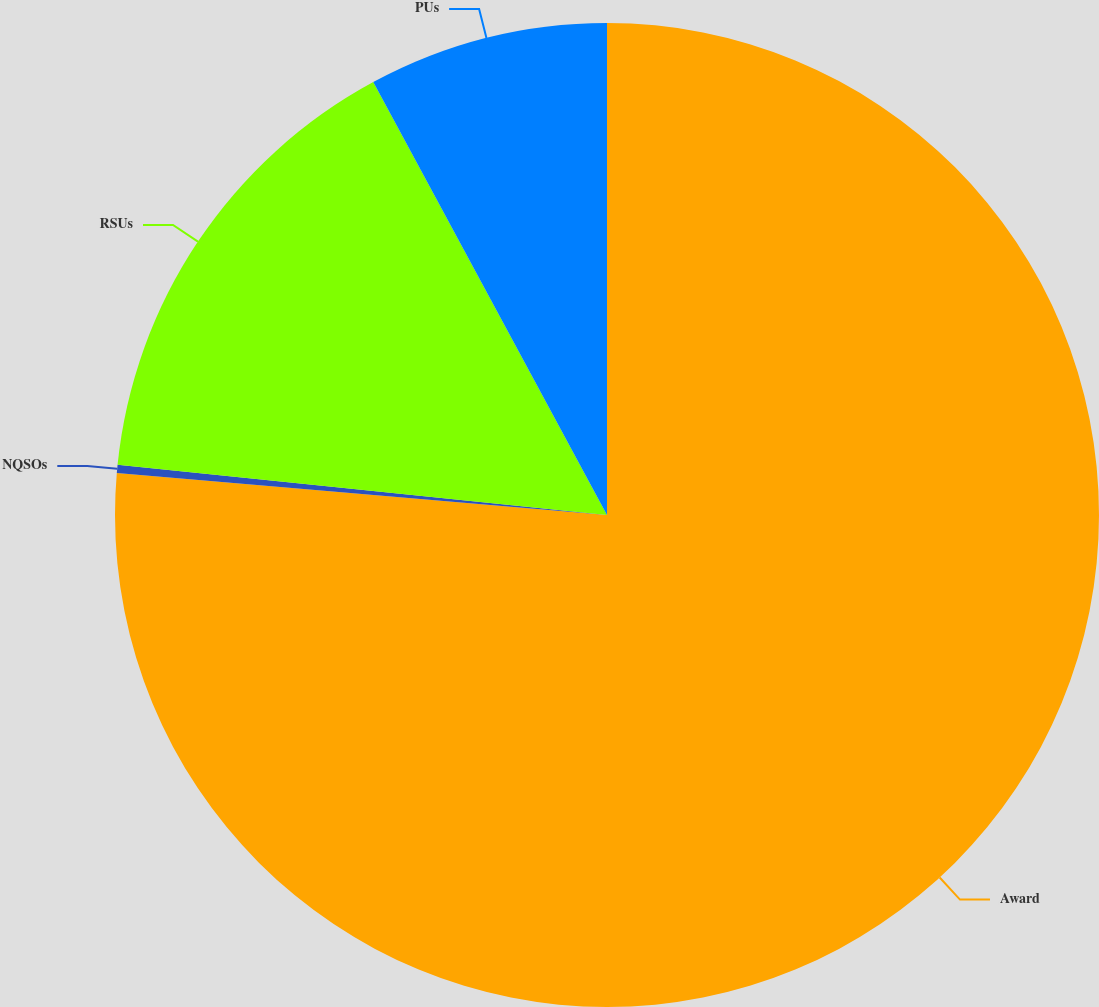<chart> <loc_0><loc_0><loc_500><loc_500><pie_chart><fcel>Award<fcel>NQSOs<fcel>RSUs<fcel>PUs<nl><fcel>76.37%<fcel>0.27%<fcel>15.49%<fcel>7.88%<nl></chart> 